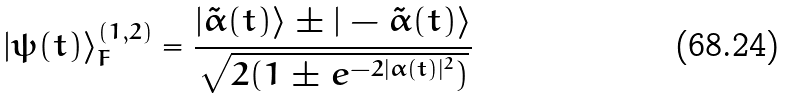Convert formula to latex. <formula><loc_0><loc_0><loc_500><loc_500>| \psi ( t ) \rangle _ { F } ^ { ( 1 , 2 ) } = \frac { | \tilde { \alpha } ( t ) \rangle \pm | - \tilde { \alpha } ( t ) \rangle } { \sqrt { 2 ( 1 \pm e ^ { - 2 | \alpha ( t ) | ^ { 2 } } ) } }</formula> 